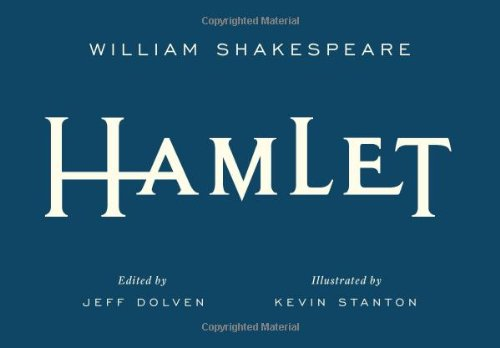What is the title of this book? The title of this book is 'Hamlet (Signature Shakespeare)', a classic tragedy penned by William Shakespeare. 